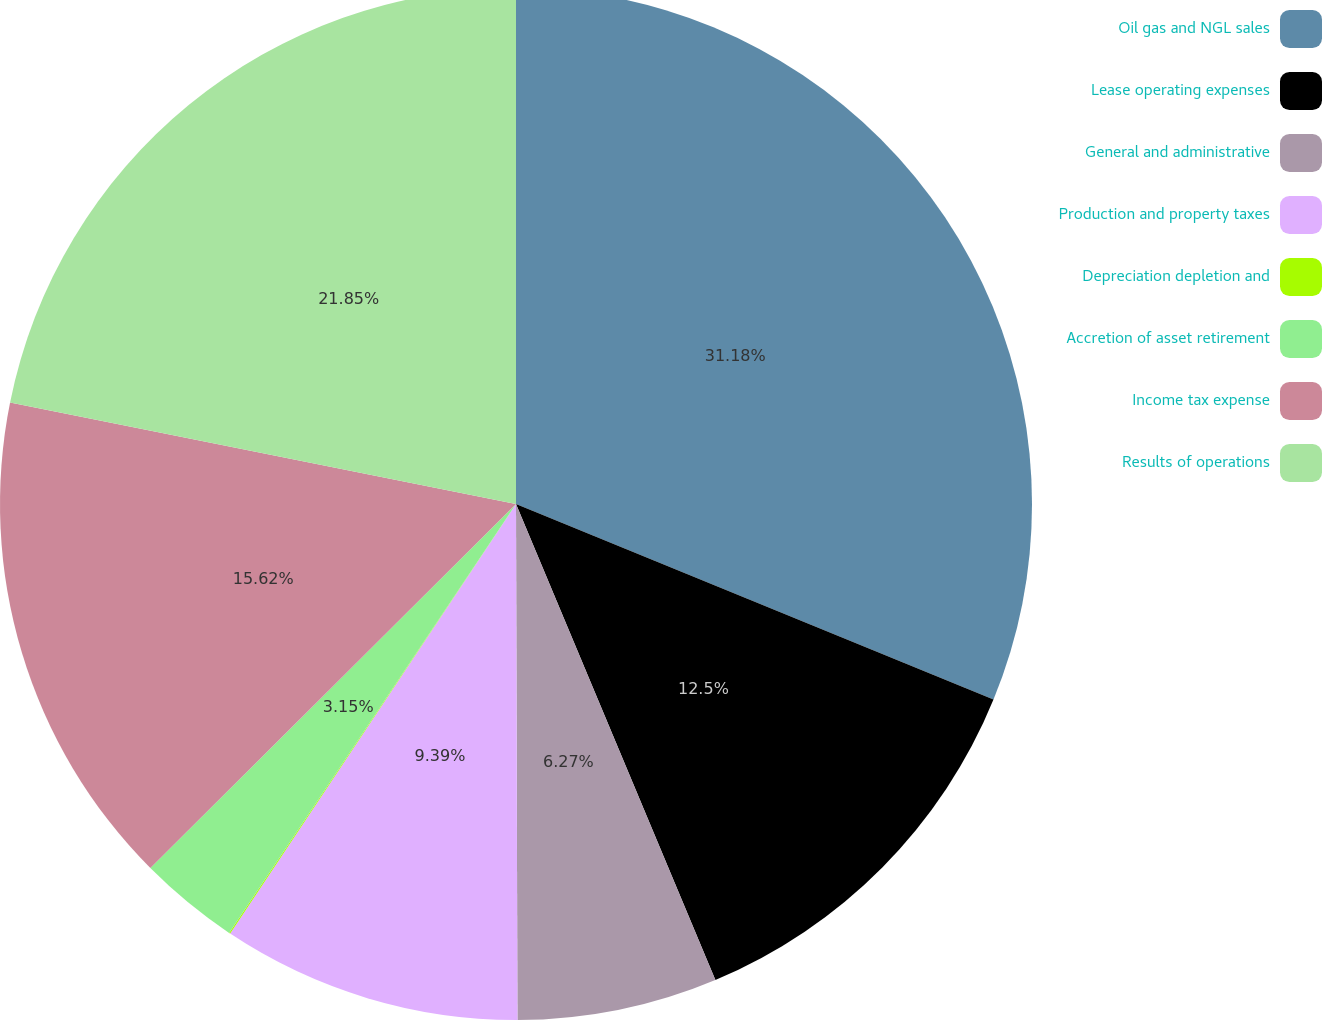Convert chart to OTSL. <chart><loc_0><loc_0><loc_500><loc_500><pie_chart><fcel>Oil gas and NGL sales<fcel>Lease operating expenses<fcel>General and administrative<fcel>Production and property taxes<fcel>Depreciation depletion and<fcel>Accretion of asset retirement<fcel>Income tax expense<fcel>Results of operations<nl><fcel>31.19%<fcel>12.5%<fcel>6.27%<fcel>9.39%<fcel>0.04%<fcel>3.15%<fcel>15.62%<fcel>21.85%<nl></chart> 